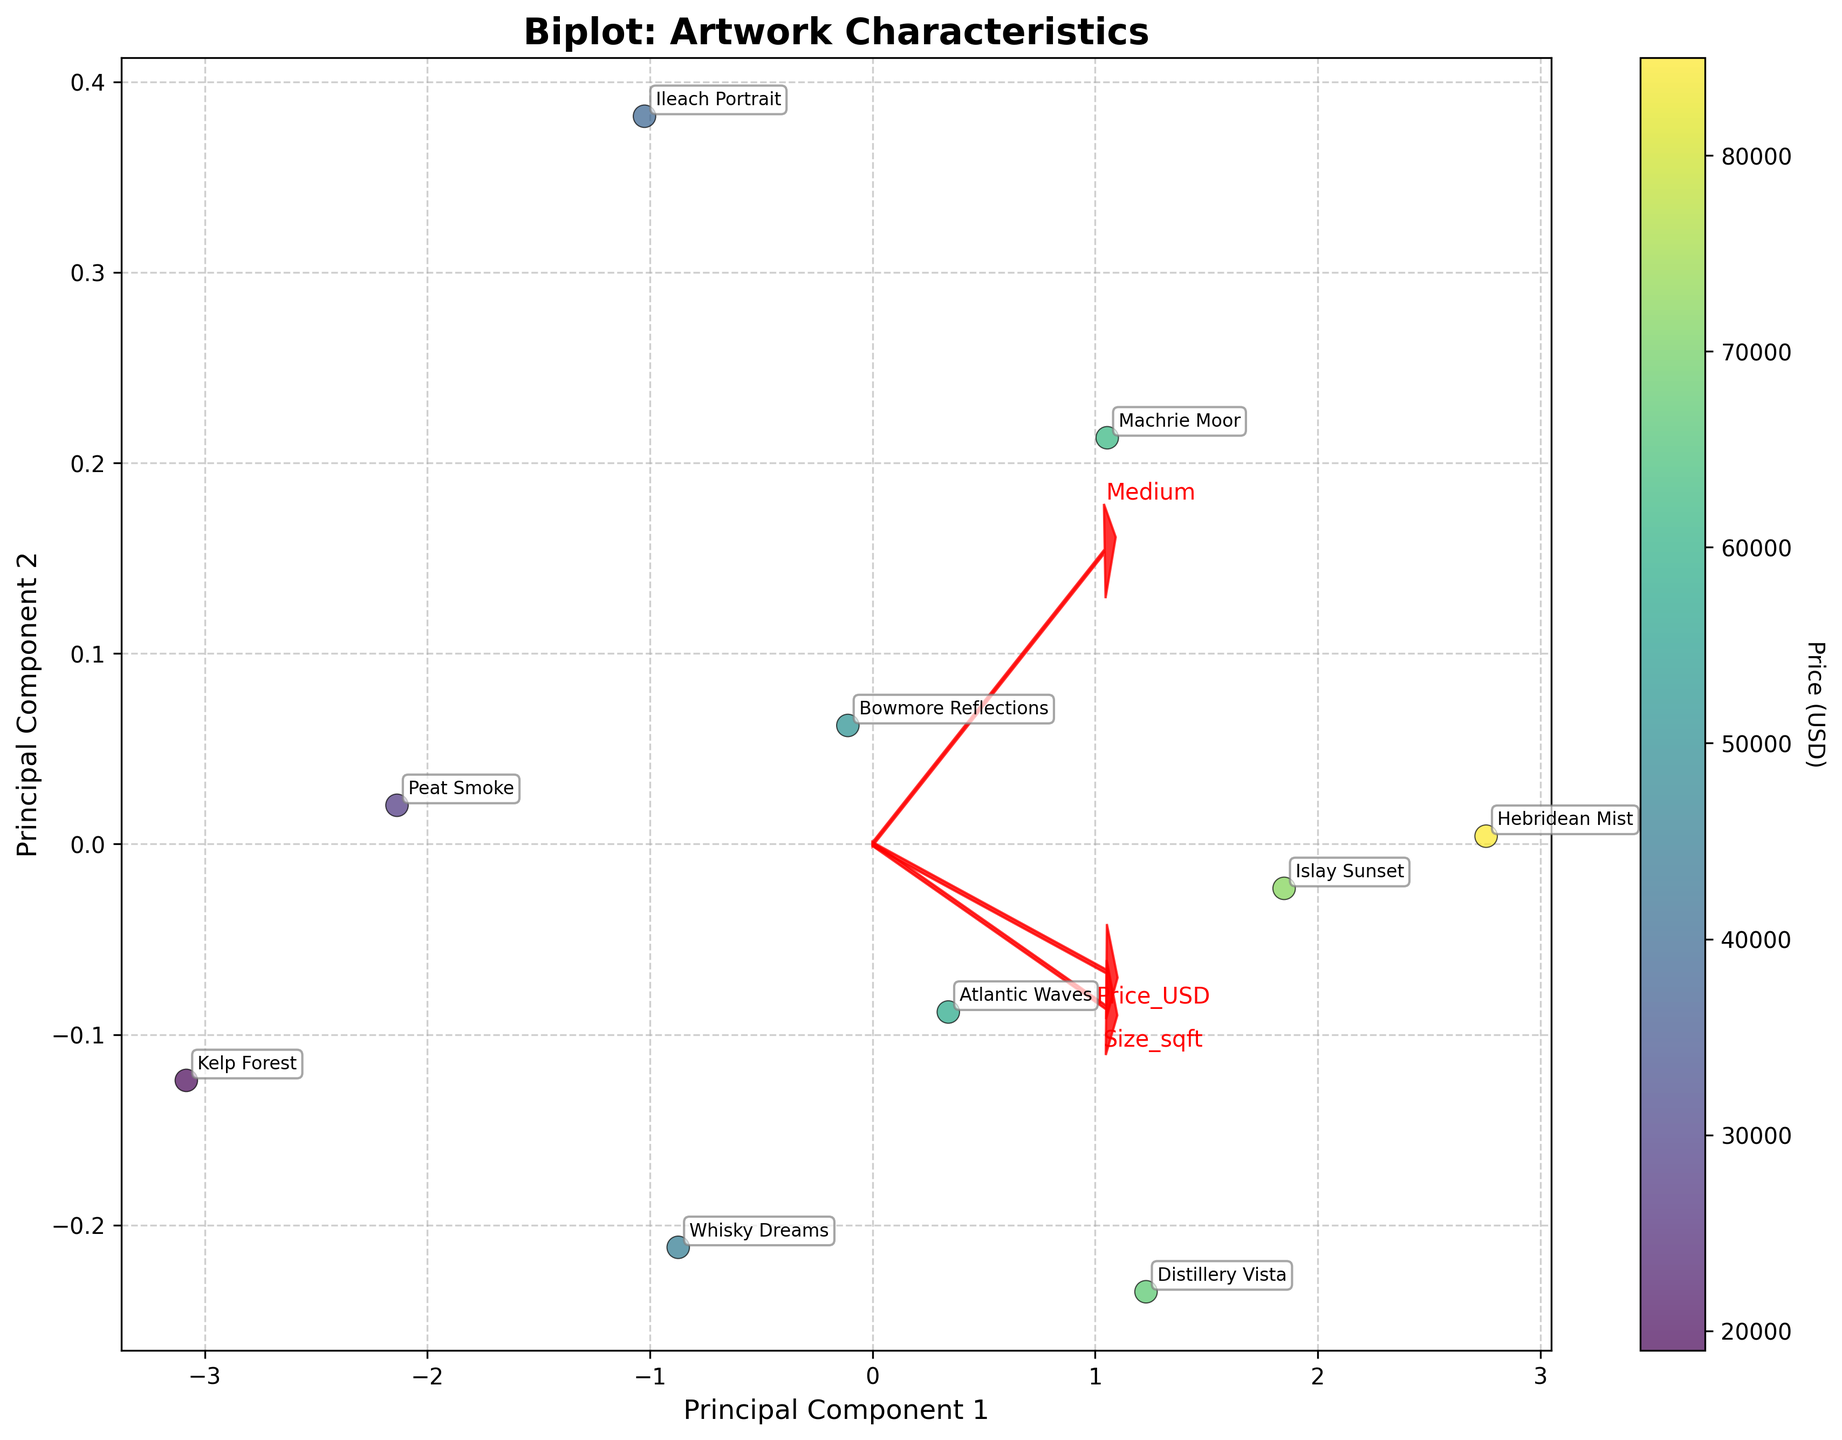What is the title of the biplot? The title of the biplot is typically located at the top of the figure. The title in this case is "Biplot: Artwork Characteristics."
Answer: Biplot: Artwork Characteristics How many data points are shown in the plot? Count the number of distinct points (circles) scattered across the plot. Each represents an artwork.
Answer: 10 Which artwork has the highest price and where is it located on the plot? Look for the data point corresponding to the highest price indicated by color intensity and refer to the annotation for the artwork's name. The artwork with the highest price is "Hebridean Mist." It's located at the upper middle area of the plot.
Answer: Hebridean Mist How are the sizes of the arrows related to the PCA components? The lengths of the arrows represent the loadings of each variable on the principal components. The directions and magnitudes indicate how strongly each variable is correlated with the components. Longer arrows signify stronger relationships.
Answer: Longer arrows signify stronger relationships Which variable has the highest loading on Principal Component 1 (PC1)? Compare the lengths of the arrows along the horizontal axis (PC1). The variable with the longest arrow aligned with PC1 has the highest loading on that component.
Answer: Artist_Reputation Which artwork is most closely associated with high artist reputation? Identify the data point closest to the end of the arrow labeled "Artist_Reputation." The closest point represents the artwork most associated with high artist reputation.
Answer: Hebridean Mist How does 'Oil on Canvas' medium compare in terms of price and size? Observe the cluster of data points labeled with 'Oil on Canvas,' and examine their locations relative to price (color intensity) and size (size of the points).
Answer: Generally higher in price and larger in size Are there any outliers in the dataset, and if so, which artworks are they? Identify any data points that are far away from the majority of other points in the biplot. These points are potential outliers.
Answer: Whisky Dreams and Hebridean Mist What is the relationship between 'Size_sqft' and 'Price_USD' as shown on the biplot? Examine the direction and length of the arrows corresponding to 'Size_sqft' and 'Price_USD.' If they have similar directions and lengths, they are positively correlated.
Answer: Positive correlation Which direction on the biplot represents an increase in 'Size_sqft'? Look at the direction of the arrow labeled 'Size_sqft.' The direction it points towards indicates the increase in size.
Answer: Right and slightly upwards 